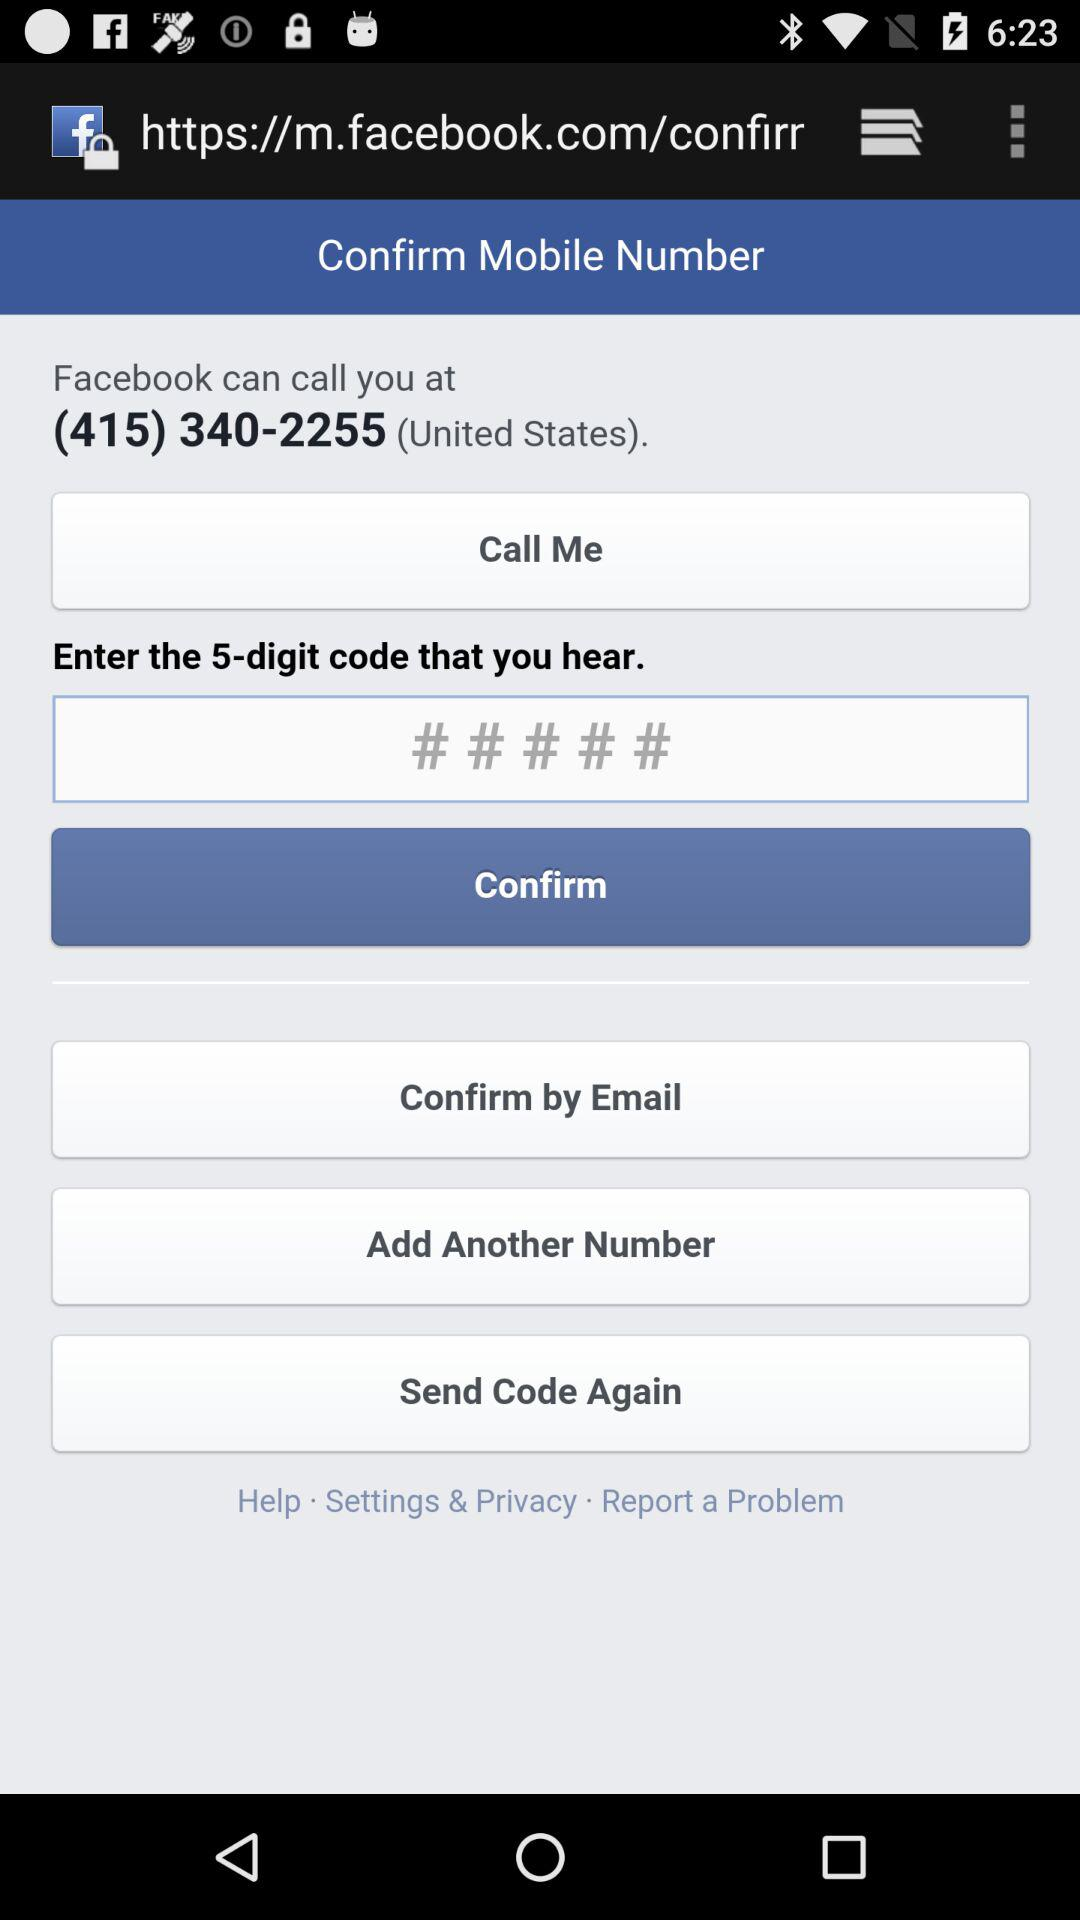How many digits is the code?
Answer the question using a single word or phrase. 5 